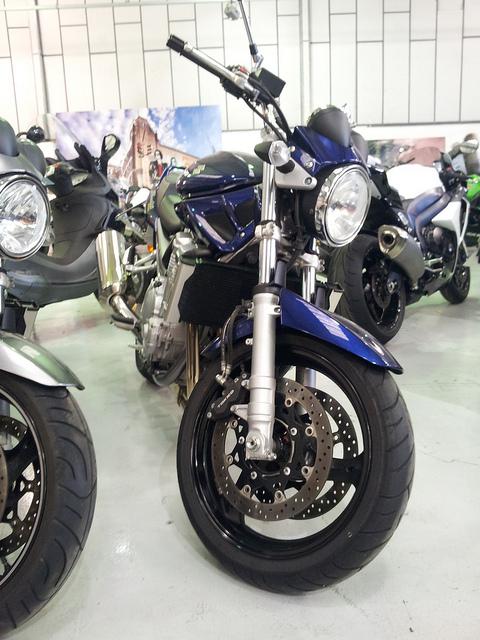Is that the front or rear tire?
Quick response, please. Front. What kind of vehicle is in the picture?
Keep it brief. Motorcycle. What color is the main cycle in this picture?
Short answer required. Blue. 